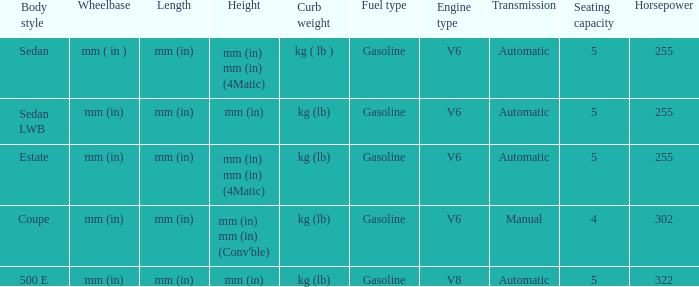Would you mind parsing the complete table? {'header': ['Body style', 'Wheelbase', 'Length', 'Height', 'Curb weight', 'Fuel type', 'Engine type', 'Transmission', 'Seating capacity', 'Horsepower'], 'rows': [['Sedan', 'mm ( in )', 'mm (in)', 'mm (in) mm (in) (4Matic)', 'kg ( lb )', 'Gasoline', 'V6', 'Automatic', '5', '255'], ['Sedan LWB', 'mm (in)', 'mm (in)', 'mm (in)', 'kg (lb)', 'Gasoline', 'V6', 'Automatic', '5', '255'], ['Estate', 'mm (in)', 'mm (in)', 'mm (in) mm (in) (4Matic)', 'kg (lb)', 'Gasoline', 'V6', 'Automatic', '5', '255'], ['Coupe', 'mm (in)', 'mm (in)', "mm (in) mm (in) (Conv'ble)", 'kg (lb)', 'Gasoline', 'V6', 'Manual', '4', '302'], ['500 E', 'mm (in)', 'mm (in)', 'mm (in)', 'kg (lb)', 'Gasoline', 'V8', 'Automatic', '5', '322']]} What are the lengths of the models that are mm (in) tall? Mm (in), mm (in). 